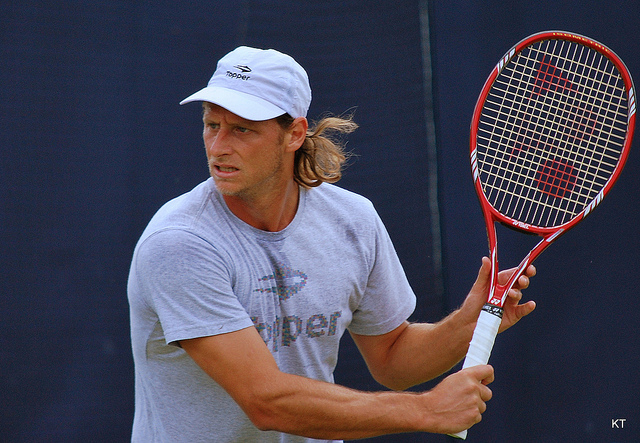Read and extract the text from this image. Topper PIPER KT 